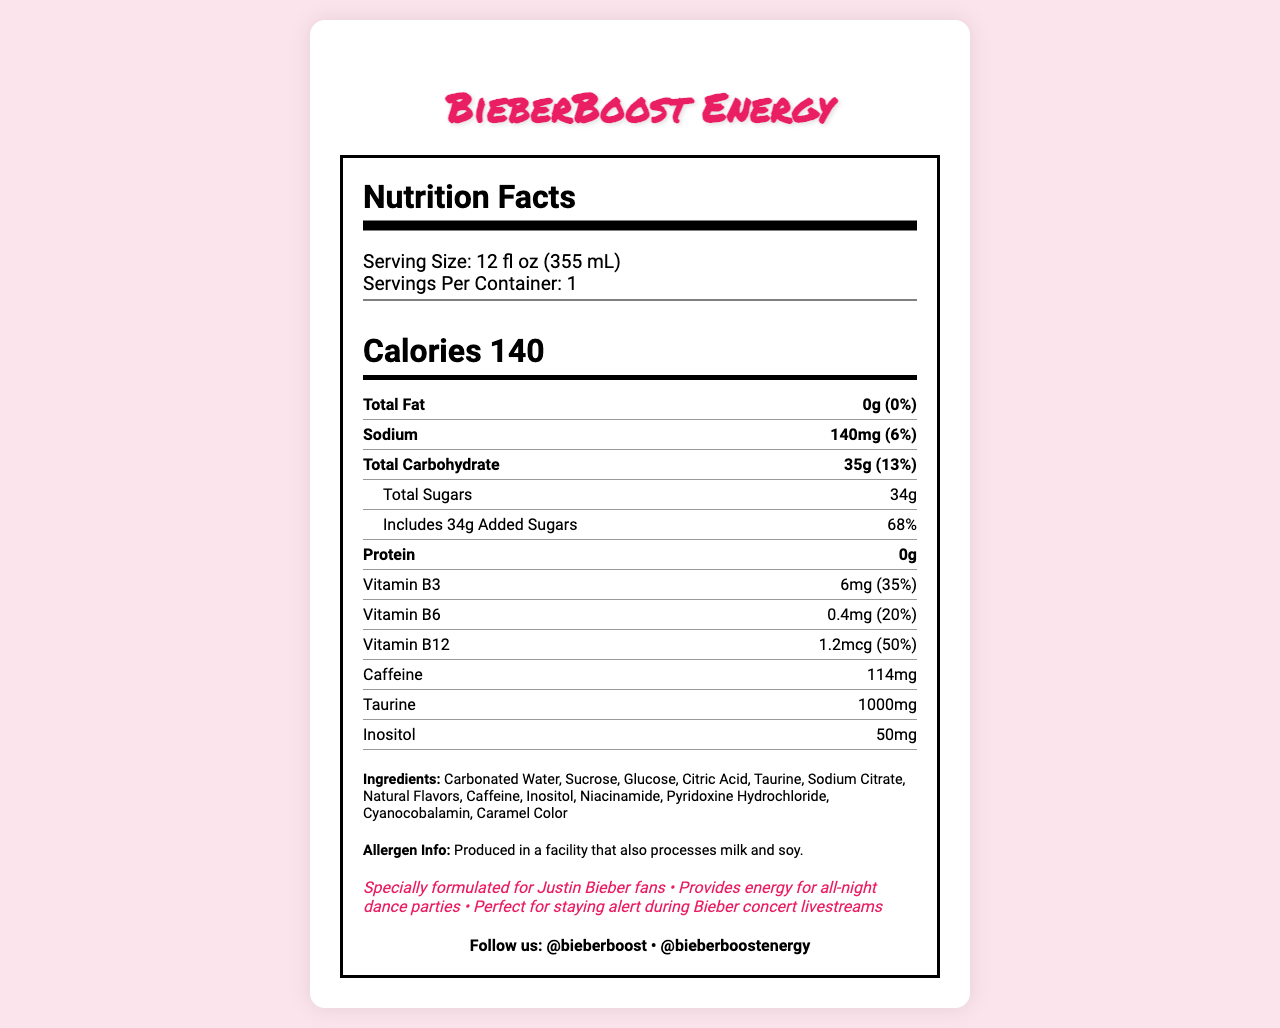what is the serving size for BieberBoost Energy? The serving size is listed as 12 fl oz (355 mL) on the document.
Answer: 12 fl oz (355 mL) how many calories are in one serving of BieberBoost Energy? The document states that there are 140 calories in one serving.
Answer: 140 what is the total fat content in BieberBoost Energy? The document indicates that the total fat content is 0g.
Answer: 0g is there any protein in BieberBoost Energy? The document shows that the protein content is 0g, so there is no protein.
Answer: No how much caffeine is there in BieberBoost Energy? The caffeine content is listed as 114mg in the document.
Answer: 114mg what percentage of daily value of added sugars is provided by BieberBoost Energy? The document states that the added sugars contribute 68% of the daily value.
Answer: 68% which ingredient is listed first in BieberBoost Energy? A. Glucose B. Citric Acid C. Carbonated Water The first ingredient listed is Carbonated Water.
Answer: C. Carbonated Water how much vitamin B12 does BieberBoost Energy contain? The document shows that Vitamin B12 content is 1.2mcg, which is 50% of the daily value.
Answer: 1.2mcg (50% DV) does BieberBoost Energy contain sodium? The document indicates that it contains 140mg of sodium, which is 6% of the daily value.
Answer: Yes what is the amount of taurine in BieberBoost Energy? The document lists the taurine content as 1000mg.
Answer: 1000mg how is BieberBoost Energy marketed towards Justin Bieber fans? The marketing claims include that it is specially formulated for fans and perfect for staying alert during concert livestreams.
Answer: The document claims it is "Specially formulated for Justin Bieber fans" and "Perfect for staying alert during Bieber concert livestreams." what are some of the social media handles for BieberBoost Energy? The document provides these social media handles in the social media section.
Answer: Instagram: @bieberboost, TikTok: @bieberboostenergy is BieberBoost Energy free of allergens? The allergen information states it is produced in a facility that processes milk and soy.
Answer: No, it is produced in a facility that also processes milk and soy. which vitamin has the highest daily value percentage in BieberBoost Energy? A. Vitamin B3 B. Vitamin B6 C. Vitamin B12 The document shows Vitamin B12 with 50% DV, which is higher than Vitamin B3 (35% DV) and B6 (20% DV).
Answer: C. Vitamin B12 summarize the main idea of the document. The summary captures the content, including nutritional information, marketing claims, social media presence, and allergen information.
Answer: BieberBoost Energy is a specially formulated energy drink for Justin Bieber fans, providing 140 calories per serving along with various nutrients and high caffeine content, aimed at keeping fans energized. It contains no fat or protein but is high in sugar and includes vitamins B3, B6, and B12. Manufactured by PopStar Beverages, Inc., it is marketed for staying alert during Bieber-related activities and has social media handles for engagement. what is the website for BieberBoost Energy? The document mentions the website in the footer section.
Answer: www.bieberboostenergy.com how does BieberBoost Energy help with Justin Bieber concert livestreams? The document's marketing claims include that the drink is perfect for staying alert during concert livestreams.
Answer: Provides energy for staying alert during Bieber concert livestreams. how many servings are there in a container of BieberBoost Energy? The document states that there is 1 serving per container.
Answer: 1 is the source of taurine in BieberBoost Energy natural? The document lists taurine as an ingredient but does not specify whether it is naturally sourced.
Answer: Cannot be determined 